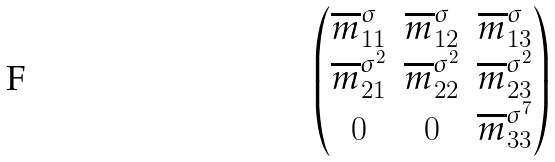<formula> <loc_0><loc_0><loc_500><loc_500>\begin{pmatrix} \overline { m } _ { 1 1 } ^ { \sigma } & \overline { m } _ { 1 2 } ^ { \sigma } & \overline { m } _ { 1 3 } ^ { \sigma } \\ \overline { m } _ { 2 1 } ^ { \sigma ^ { 2 } } & \overline { m } _ { 2 2 } ^ { \sigma ^ { 2 } } & \overline { m } _ { 2 3 } ^ { \sigma ^ { 2 } } \\ 0 & 0 & \overline { m } _ { 3 3 } ^ { \sigma ^ { 7 } } \end{pmatrix}</formula> 